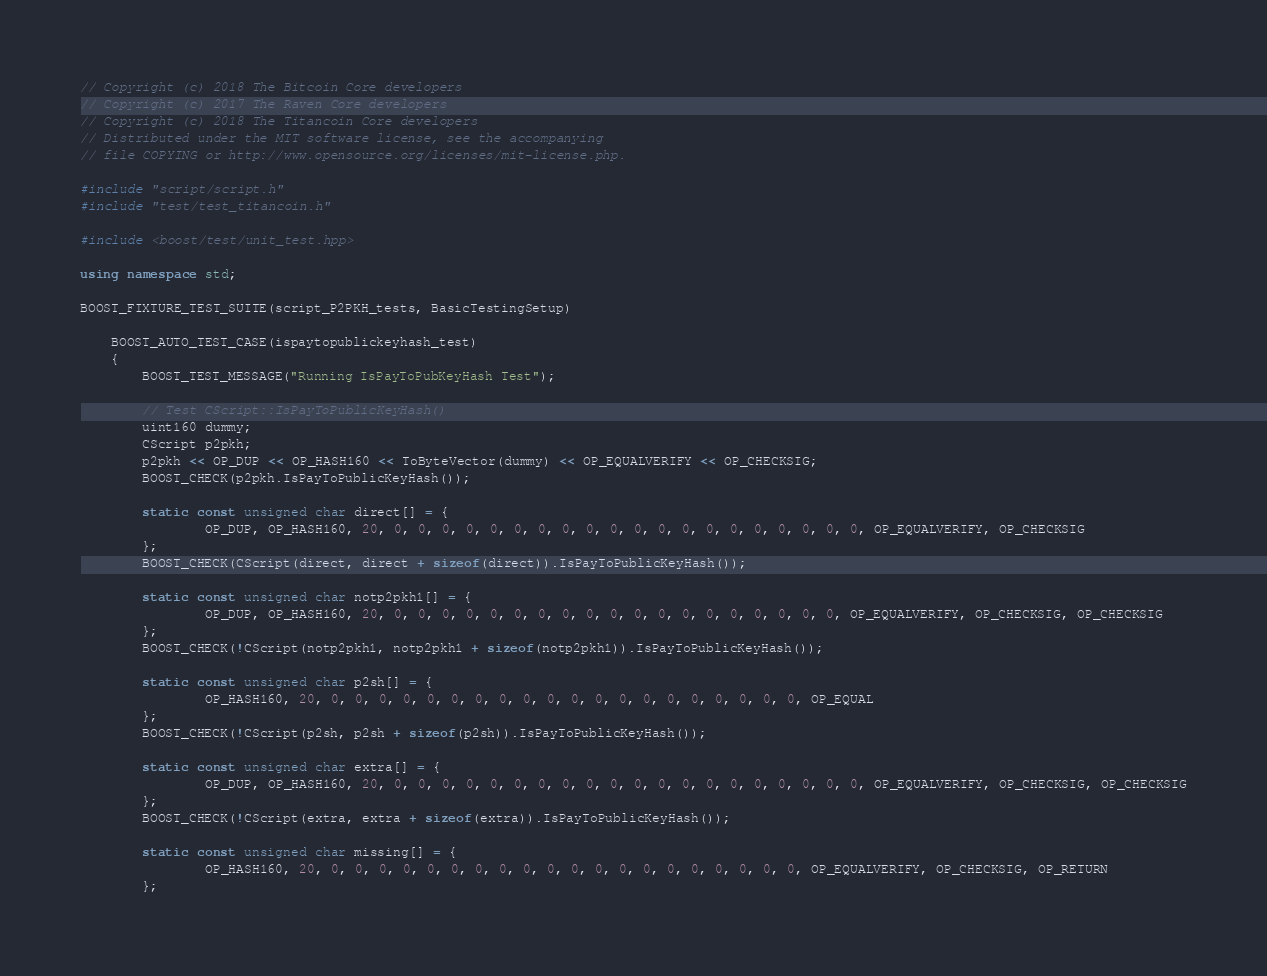<code> <loc_0><loc_0><loc_500><loc_500><_C++_>// Copyright (c) 2018 The Bitcoin Core developers
// Copyright (c) 2017 The Raven Core developers
// Copyright (c) 2018 The Titancoin Core developers
// Distributed under the MIT software license, see the accompanying
// file COPYING or http://www.opensource.org/licenses/mit-license.php.

#include "script/script.h"
#include "test/test_titancoin.h"

#include <boost/test/unit_test.hpp>

using namespace std;

BOOST_FIXTURE_TEST_SUITE(script_P2PKH_tests, BasicTestingSetup)

    BOOST_AUTO_TEST_CASE(ispaytopublickeyhash_test)
    {
        BOOST_TEST_MESSAGE("Running IsPayToPubKeyHash Test");

        // Test CScript::IsPayToPublicKeyHash()
        uint160 dummy;
        CScript p2pkh;
        p2pkh << OP_DUP << OP_HASH160 << ToByteVector(dummy) << OP_EQUALVERIFY << OP_CHECKSIG;
        BOOST_CHECK(p2pkh.IsPayToPublicKeyHash());

        static const unsigned char direct[] = {
                OP_DUP, OP_HASH160, 20, 0, 0, 0, 0, 0, 0, 0, 0, 0, 0, 0, 0, 0, 0, 0, 0, 0, 0, 0, 0, OP_EQUALVERIFY, OP_CHECKSIG
        };
        BOOST_CHECK(CScript(direct, direct + sizeof(direct)).IsPayToPublicKeyHash());

        static const unsigned char notp2pkh1[] = {
                OP_DUP, OP_HASH160, 20, 0, 0, 0, 0, 0, 0, 0, 0, 0, 0, 0, 0, 0, 0, 0, 0, 0, 0, 0, OP_EQUALVERIFY, OP_CHECKSIG, OP_CHECKSIG
        };
        BOOST_CHECK(!CScript(notp2pkh1, notp2pkh1 + sizeof(notp2pkh1)).IsPayToPublicKeyHash());

        static const unsigned char p2sh[] = {
                OP_HASH160, 20, 0, 0, 0, 0, 0, 0, 0, 0, 0, 0, 0, 0, 0, 0, 0, 0, 0, 0, 0, 0, OP_EQUAL
        };
        BOOST_CHECK(!CScript(p2sh, p2sh + sizeof(p2sh)).IsPayToPublicKeyHash());

        static const unsigned char extra[] = {
                OP_DUP, OP_HASH160, 20, 0, 0, 0, 0, 0, 0, 0, 0, 0, 0, 0, 0, 0, 0, 0, 0, 0, 0, 0, 0, OP_EQUALVERIFY, OP_CHECKSIG, OP_CHECKSIG
        };
        BOOST_CHECK(!CScript(extra, extra + sizeof(extra)).IsPayToPublicKeyHash());

        static const unsigned char missing[] = {
                OP_HASH160, 20, 0, 0, 0, 0, 0, 0, 0, 0, 0, 0, 0, 0, 0, 0, 0, 0, 0, 0, 0, 0, OP_EQUALVERIFY, OP_CHECKSIG, OP_RETURN
        };</code> 